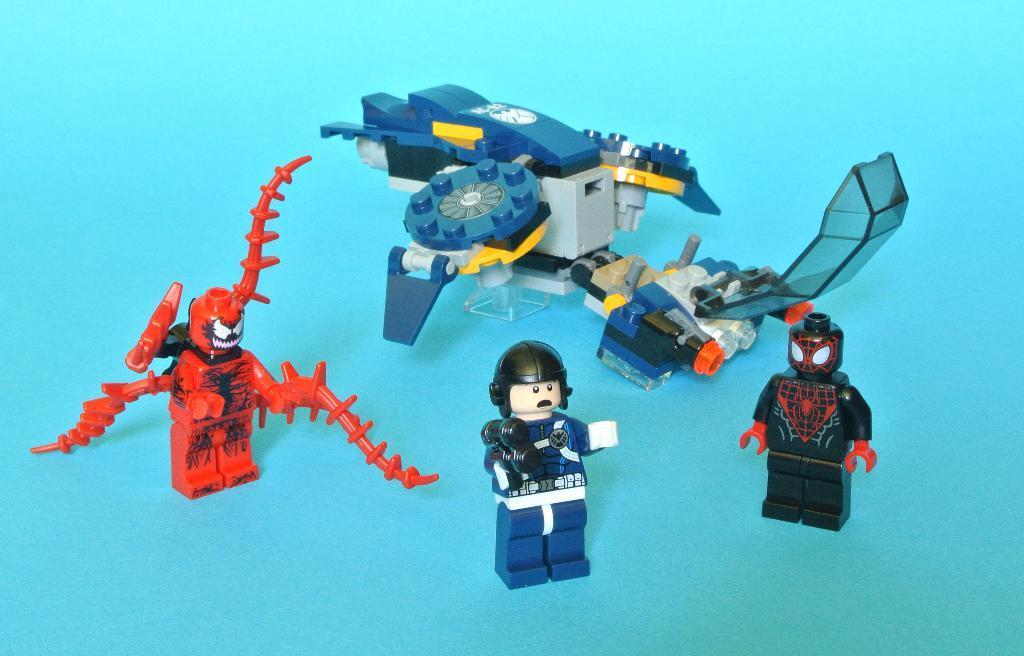Could you give a brief overview of what you see in this image? In this picture I can see few miniatures and I can see blue color background. 